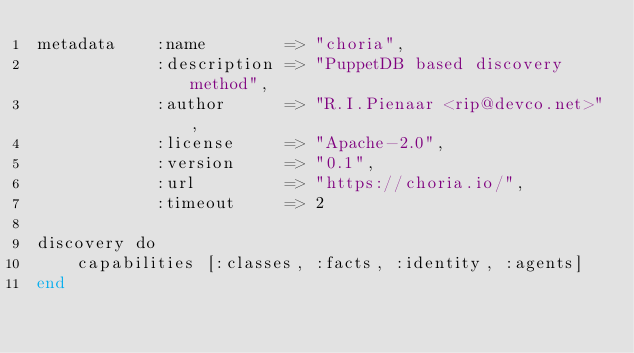<code> <loc_0><loc_0><loc_500><loc_500><_SQL_>metadata    :name        => "choria",
            :description => "PuppetDB based discovery method",
            :author      => "R.I.Pienaar <rip@devco.net>",
            :license     => "Apache-2.0",
            :version     => "0.1",
            :url         => "https://choria.io/",
            :timeout     => 2

discovery do
    capabilities [:classes, :facts, :identity, :agents]
end


</code> 